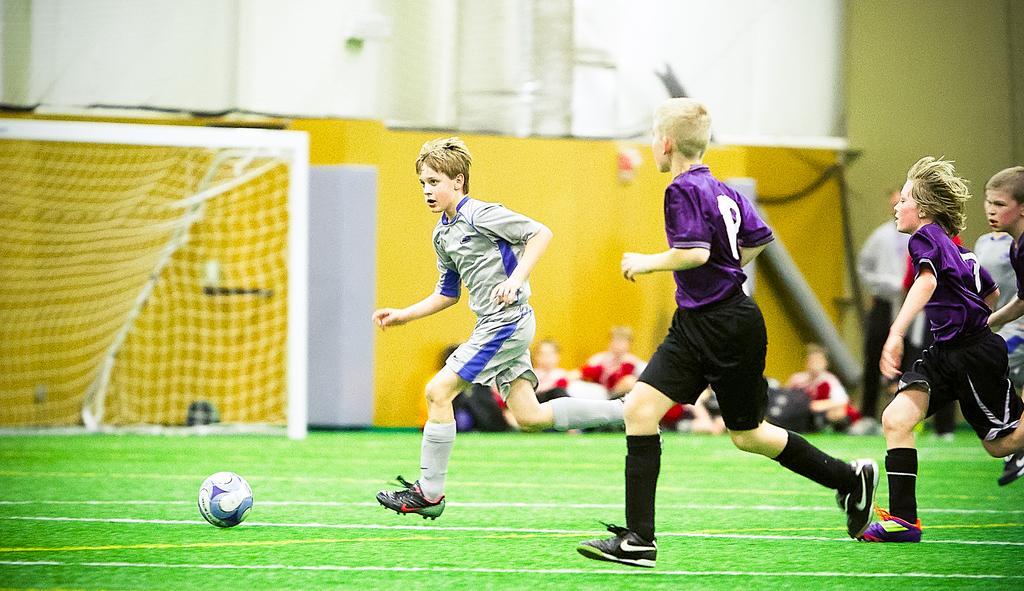How would you summarize this image in a sentence or two? In this image I can see there are children's playing a game on the ground and in the middle I can see yellow color fence , in front of the fence I can see some persons sitting on the ground ,at the top I can see the wall. 